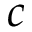<formula> <loc_0><loc_0><loc_500><loc_500>c</formula> 